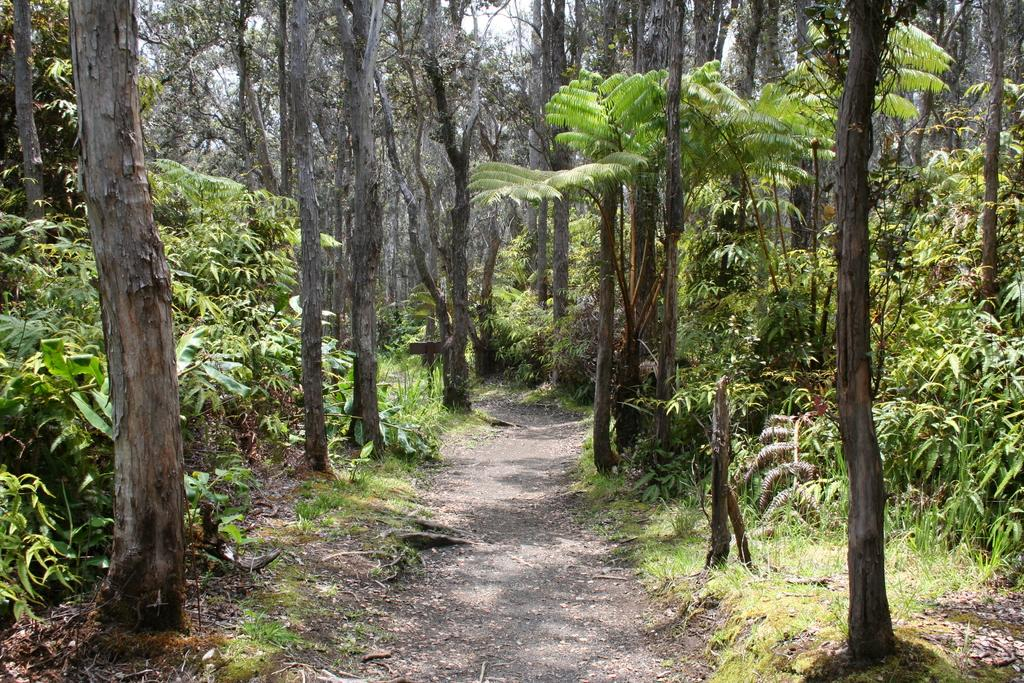What type of surface can be seen at the bottom of the image? The ground is visible in the image. What type of vegetation is present on the ground? There is grass in the image. What other types of vegetation can be seen in the image? There are plants and trees in the image. What is visible above the vegetation in the image? The sky is visible in the image. Where is the mailbox located in the image? There is no mailbox present in the image. How many accounts does the plant have in the image? There are no accounts associated with the plants in the image. 